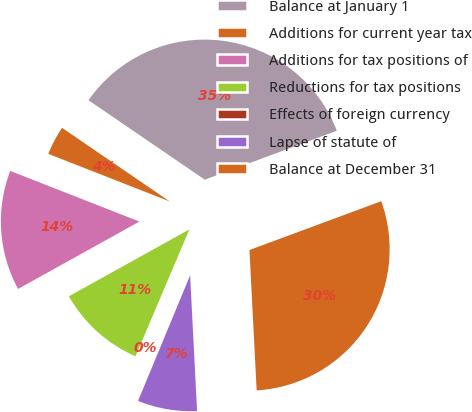<chart> <loc_0><loc_0><loc_500><loc_500><pie_chart><fcel>Balance at January 1<fcel>Additions for current year tax<fcel>Additions for tax positions of<fcel>Reductions for tax positions<fcel>Effects of foreign currency<fcel>Lapse of statute of<fcel>Balance at December 31<nl><fcel>34.81%<fcel>3.6%<fcel>14.01%<fcel>10.54%<fcel>0.14%<fcel>7.07%<fcel>29.83%<nl></chart> 